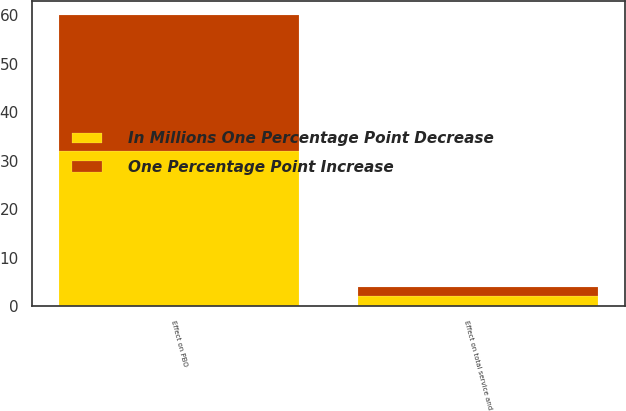Convert chart to OTSL. <chart><loc_0><loc_0><loc_500><loc_500><stacked_bar_chart><ecel><fcel>Effect on total service and<fcel>Effect on PBO<nl><fcel>In Millions One Percentage Point Decrease<fcel>2<fcel>32<nl><fcel>One Percentage Point Increase<fcel>2<fcel>28<nl></chart> 